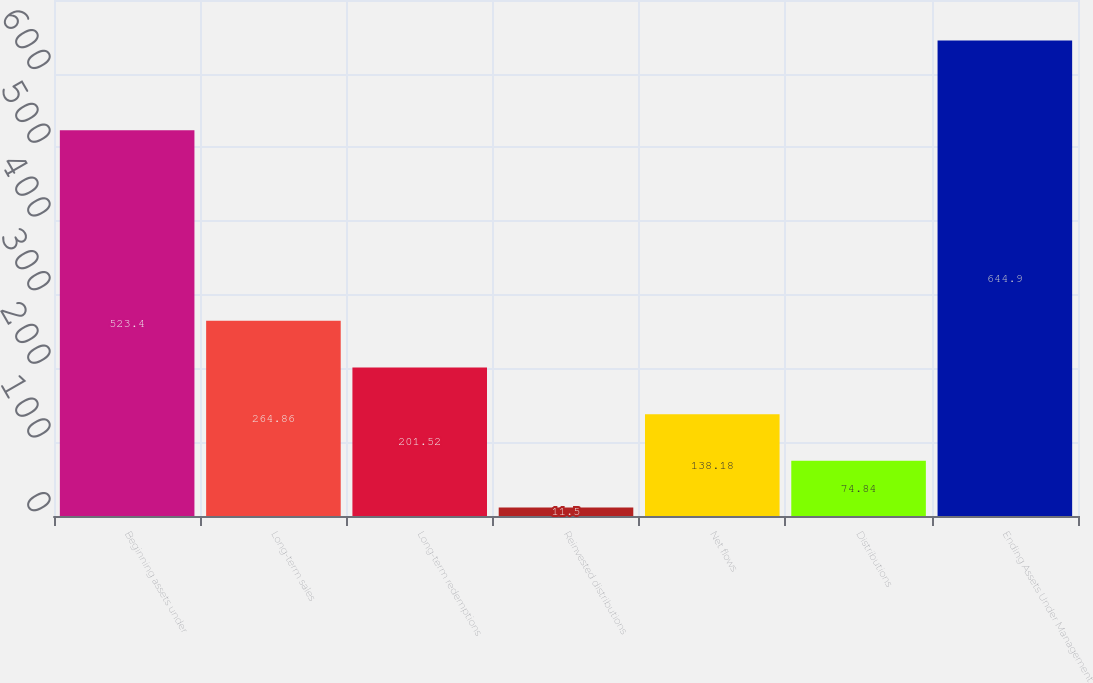Convert chart. <chart><loc_0><loc_0><loc_500><loc_500><bar_chart><fcel>Beginning assets under<fcel>Long-term sales<fcel>Long-term redemptions<fcel>Reinvested distributions<fcel>Net flows<fcel>Distributions<fcel>Ending Assets Under Management<nl><fcel>523.4<fcel>264.86<fcel>201.52<fcel>11.5<fcel>138.18<fcel>74.84<fcel>644.9<nl></chart> 